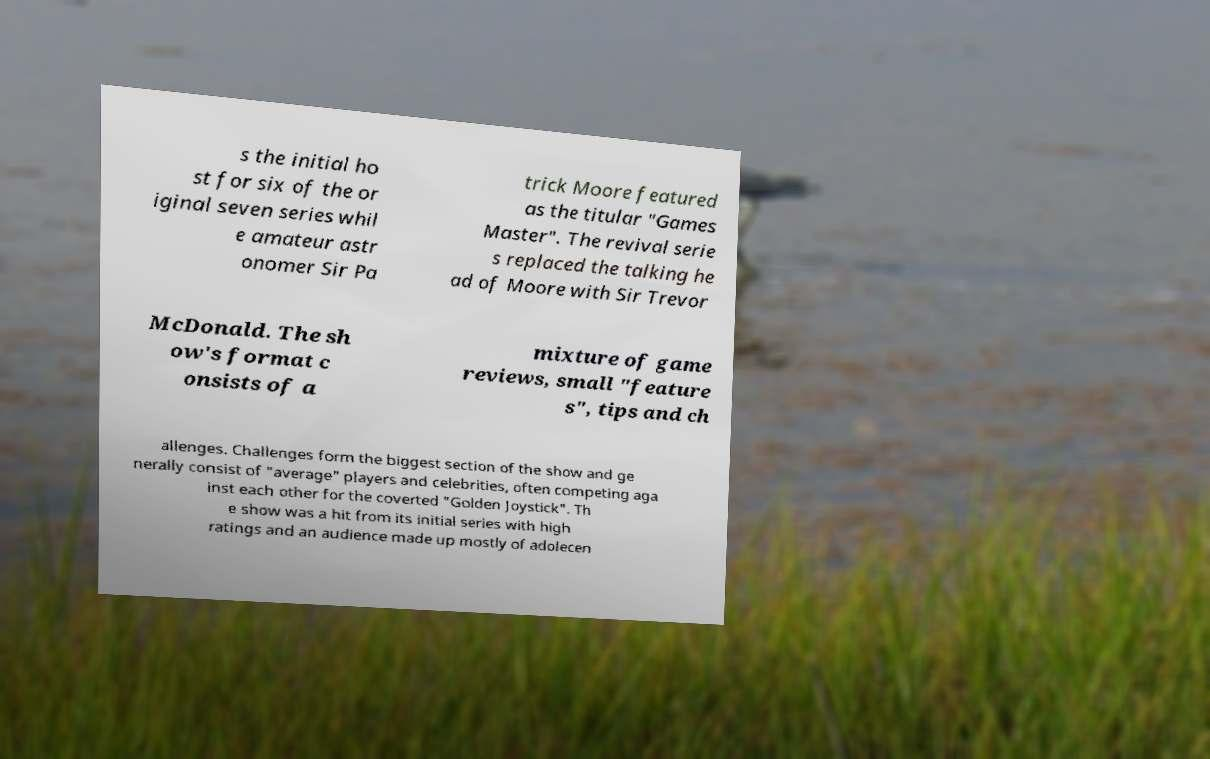Could you assist in decoding the text presented in this image and type it out clearly? s the initial ho st for six of the or iginal seven series whil e amateur astr onomer Sir Pa trick Moore featured as the titular "Games Master". The revival serie s replaced the talking he ad of Moore with Sir Trevor McDonald. The sh ow's format c onsists of a mixture of game reviews, small "feature s", tips and ch allenges. Challenges form the biggest section of the show and ge nerally consist of "average" players and celebrities, often competing aga inst each other for the coverted "Golden Joystick". Th e show was a hit from its initial series with high ratings and an audience made up mostly of adolecen 